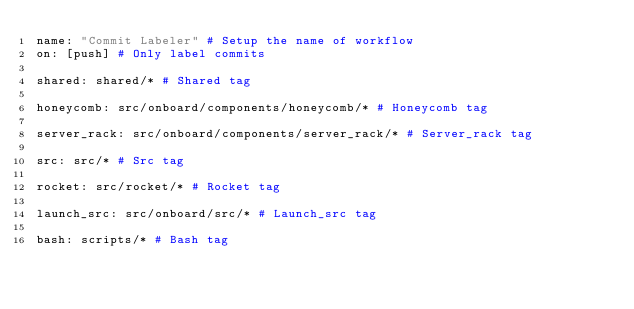<code> <loc_0><loc_0><loc_500><loc_500><_YAML_>name: "Commit Labeler" # Setup the name of workflow
on: [push] # Only label commits

shared: shared/* # Shared tag
 
honeycomb: src/onboard/components/honeycomb/* # Honeycomb tag

server_rack: src/onboard/components/server_rack/* # Server_rack tag

src: src/* # Src tag
                            
rocket: src/rocket/* # Rocket tag

launch_src: src/onboard/src/* # Launch_src tag

bash: scripts/* # Bash tag
</code> 